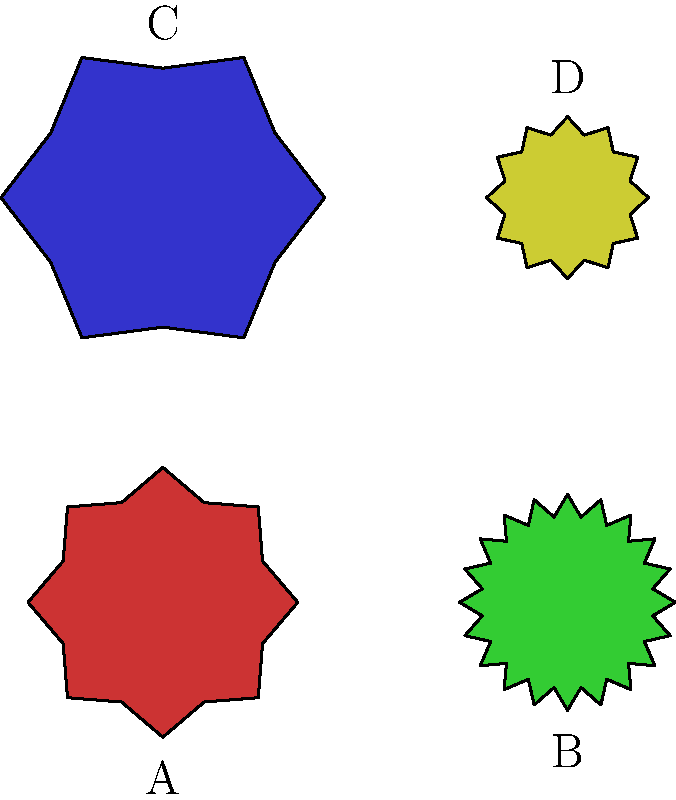Identify the type of gear represented by shape C in the image. How does its function differ from the others? To identify the gear type and understand its function, let's analyze the visual characteristics of each gear:

1. Shape C (blue gear):
   - Has the largest diameter
   - Features the fewest number of teeth (6)
   - Teeth are larger and more widely spaced

2. Other gears:
   - A (red): Medium-sized with 8 teeth
   - B (green): Smaller with many teeth (20)
   - D (yellow): Smallest with 12 teeth

Based on these observations:

1. Shape C represents a spur gear with low tooth count, often called a "low-speed, high-torque" gear.
2. Its function differs from the others in the following ways:
   a) Torque multiplication: Due to its larger size and fewer teeth, it can generate more torque.
   b) Speed reduction: When paired with smaller gears, it reduces the output speed.
   c) Force distribution: The larger teeth allow for better force distribution, making it suitable for heavy loads.

3. Compared to the other gears:
   - It rotates slower than gears with more teeth (like B)
   - It can handle higher loads than smaller gears (like D)
   - It provides a greater mechanical advantage in terms of torque

In mechanical systems, this type of gear is often used in applications requiring high torque and lower speeds, such as in heavy machinery or automotive drivetrains.
Answer: Low-speed, high-torque spur gear 